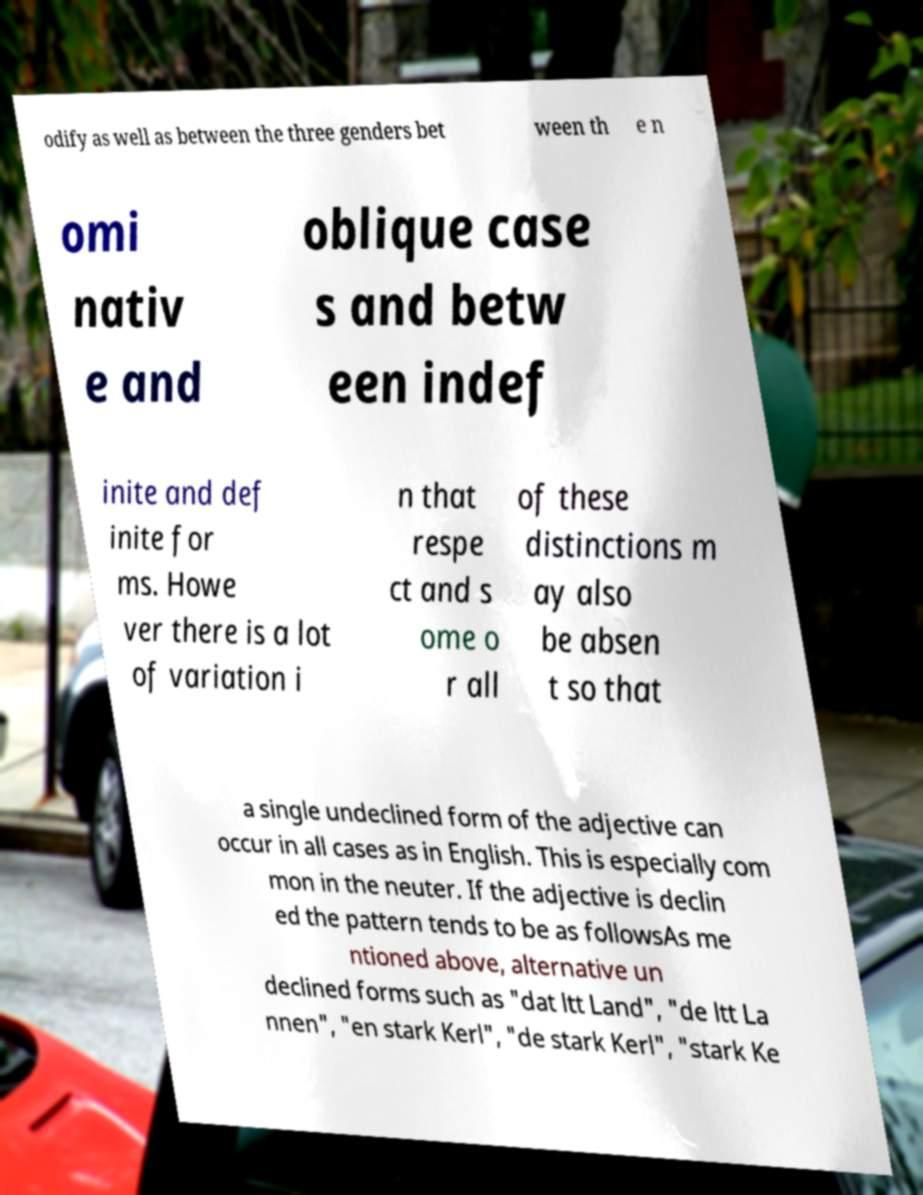Could you assist in decoding the text presented in this image and type it out clearly? odify as well as between the three genders bet ween th e n omi nativ e and oblique case s and betw een indef inite and def inite for ms. Howe ver there is a lot of variation i n that respe ct and s ome o r all of these distinctions m ay also be absen t so that a single undeclined form of the adjective can occur in all cases as in English. This is especially com mon in the neuter. If the adjective is declin ed the pattern tends to be as followsAs me ntioned above, alternative un declined forms such as "dat ltt Land", "de ltt La nnen", "en stark Kerl", "de stark Kerl", "stark Ke 